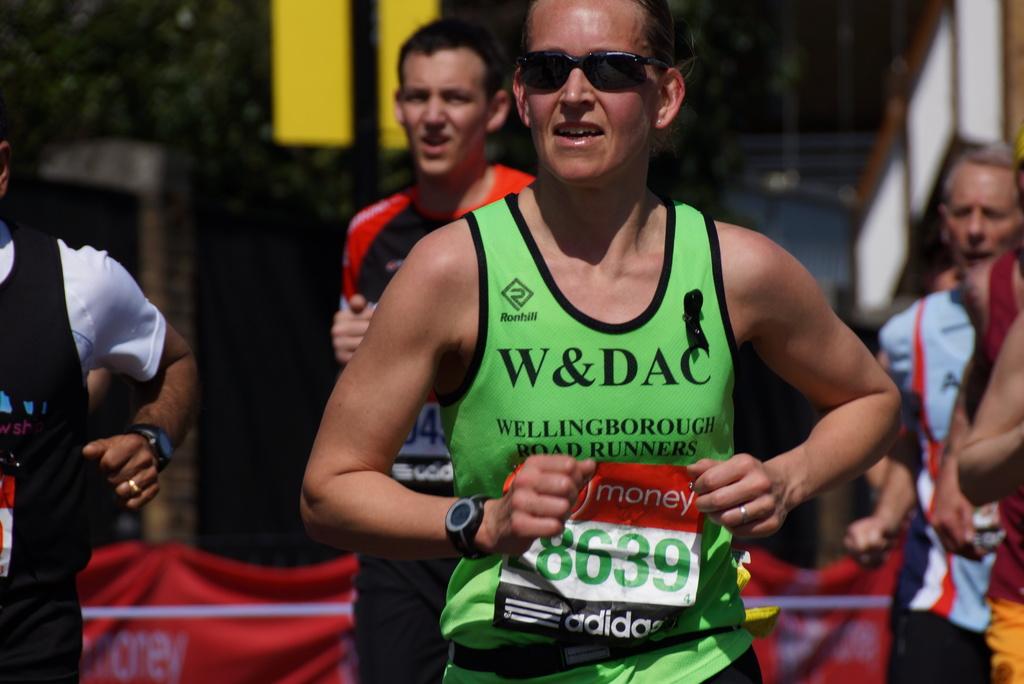What is the runner's number?
Ensure brevity in your answer.  8639. 